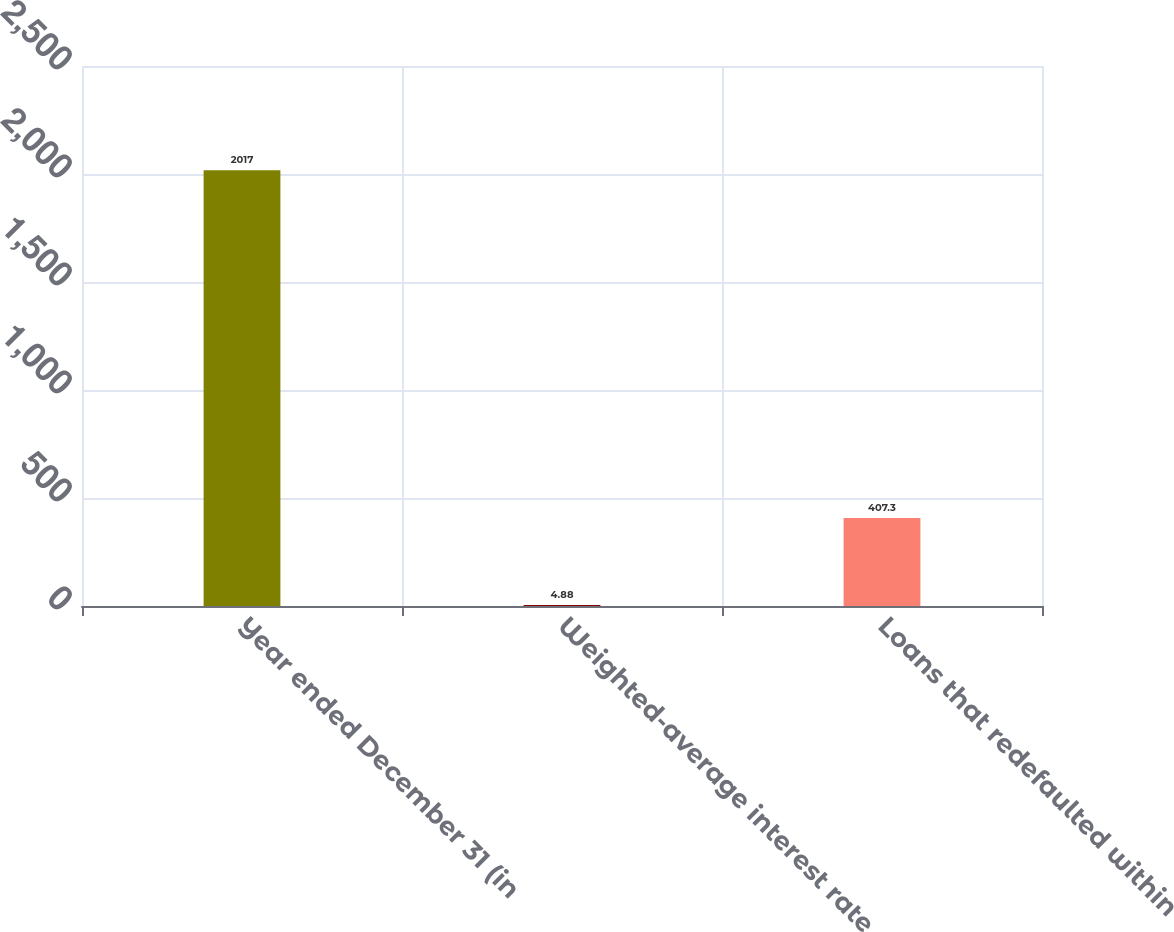<chart> <loc_0><loc_0><loc_500><loc_500><bar_chart><fcel>Year ended December 31 (in<fcel>Weighted-average interest rate<fcel>Loans that redefaulted within<nl><fcel>2017<fcel>4.88<fcel>407.3<nl></chart> 